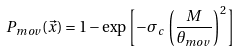Convert formula to latex. <formula><loc_0><loc_0><loc_500><loc_500>P _ { m o v } ( \vec { x } ) = 1 - \exp \left [ - \sigma _ { c } \, \left ( \frac { M } { \theta _ { m o v } } \right ) ^ { 2 } \right ]</formula> 